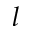Convert formula to latex. <formula><loc_0><loc_0><loc_500><loc_500>l</formula> 